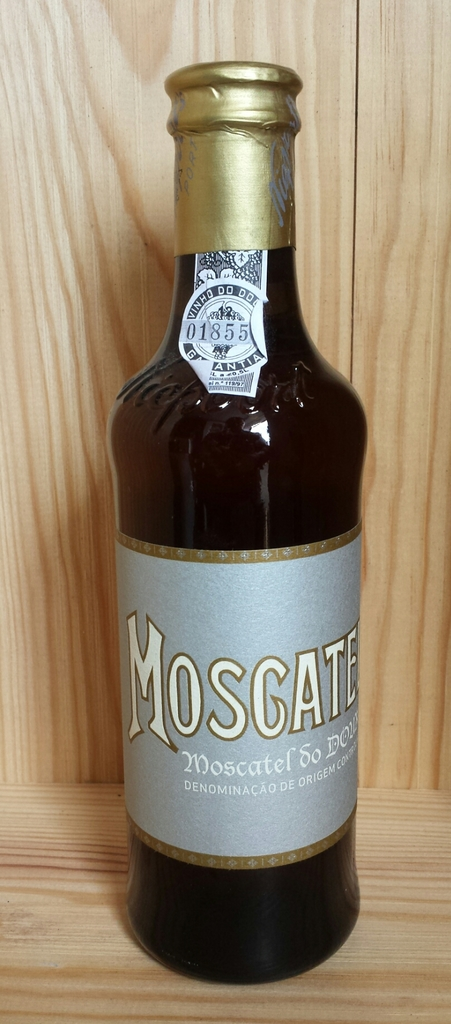What year does the number 01855 on the label refer to, and why might it be important? The number 01855 on the Moscatel bottle likely refers to a production batch number or a specific detail related to the production process. It's important for tracking the product's manufacturing details and could possibly relate to a vintage if clarified by the producer. 